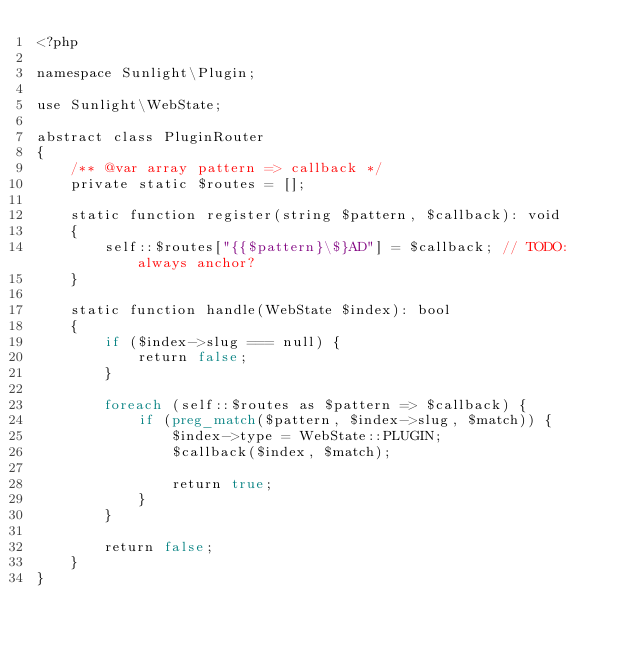Convert code to text. <code><loc_0><loc_0><loc_500><loc_500><_PHP_><?php

namespace Sunlight\Plugin;

use Sunlight\WebState;

abstract class PluginRouter
{
    /** @var array pattern => callback */
    private static $routes = [];

    static function register(string $pattern, $callback): void
    {
        self::$routes["{{$pattern}\$}AD"] = $callback; // TODO: always anchor?
    }

    static function handle(WebState $index): bool
    {
        if ($index->slug === null) {
            return false;
        }

        foreach (self::$routes as $pattern => $callback) {
            if (preg_match($pattern, $index->slug, $match)) {
                $index->type = WebState::PLUGIN;
                $callback($index, $match);

                return true;
            }
        }

        return false;
    }
}
</code> 